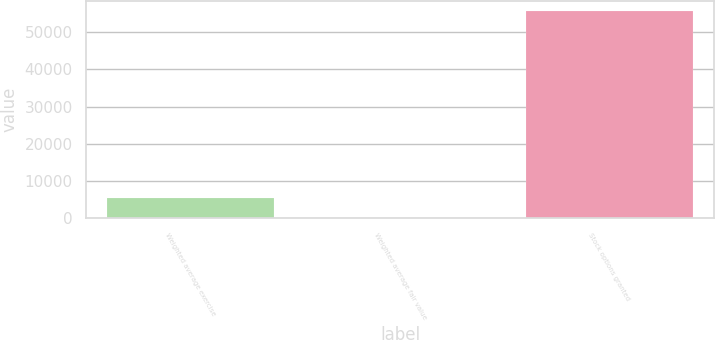<chart> <loc_0><loc_0><loc_500><loc_500><bar_chart><fcel>Weighted average exercise<fcel>Weighted average fair value<fcel>Stock options granted<nl><fcel>5567.64<fcel>0.93<fcel>55668<nl></chart> 